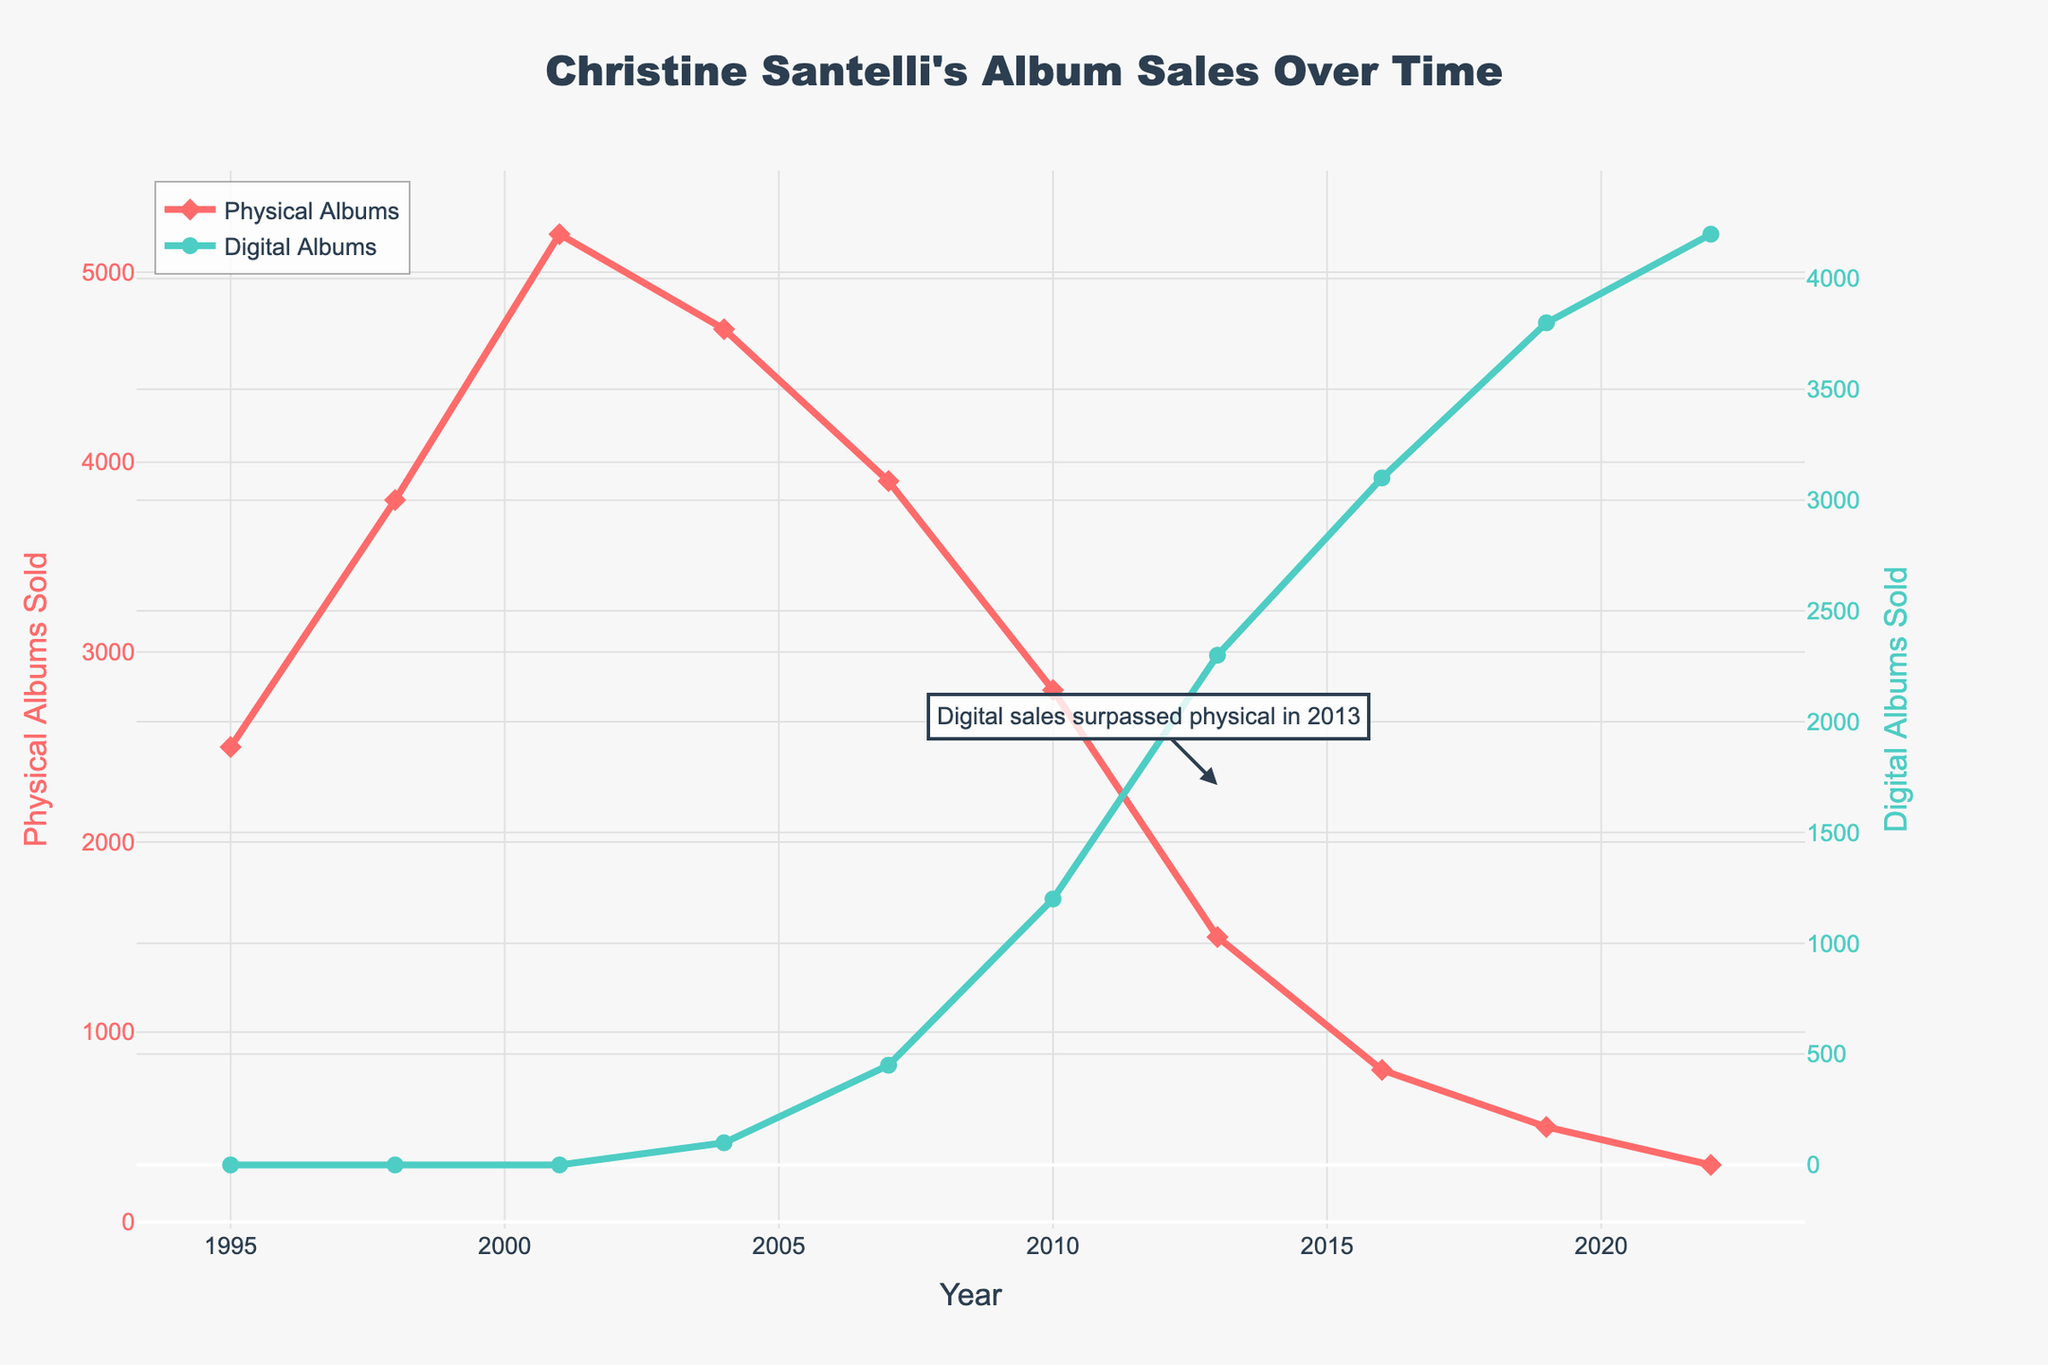What year did digital album sales first surpass physical album sales? Digital sales surpassed physical in 2013, as annotated on the graph.
Answer: 2013 In which year did Christine Santelli sell the most physical albums? Checking the highest point on the red line for physical albums, 2001 has the peak with 5200 albums sold.
Answer: 2001 By how much did physical album sales decrease from 2001 to 2004? From 5200 in 2001 to 4700 in 2004, the decrease is 5200 - 4700 = 500 albums.
Answer: 500 What is the difference in digital album sales between 2016 and 2022? Comparing the green line for 2016 (3100) and 2022 (4200), the difference is 4200 - 3100 = 1100 albums.
Answer: 1100 How do physical album sales in 1995 compare to 2022? Physical sales were 2500 in 1995 and reduced to 300 in 2022. Thus, 2500 - 300 = 2200 lower.
Answer: 2200 lower What are the total album sales (physical + digital) for 2007? Adding physical (3900) and digital (450) sales, the total is 3900 + 450 = 4350 albums.
Answer: 4350 Between which consecutive years did digital album sales show the largest increase? The biggest increase is from 2010 (1200) to 2013 (2300), with a difference of 2300 - 1200 = 1100 albums.
Answer: 2010 to 2013 What visual difference can you observe in the markers used for physical and digital album sales? Physical album sales are marked with diamond shapes, while digital album sales are marked with circles.
Answer: Shape difference 